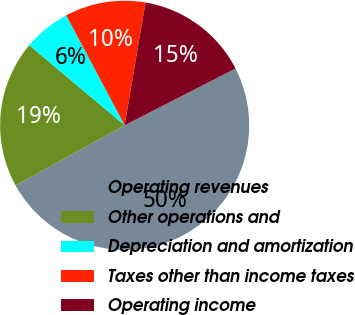Convert chart to OTSL. <chart><loc_0><loc_0><loc_500><loc_500><pie_chart><fcel>Operating revenues<fcel>Other operations and<fcel>Depreciation and amortization<fcel>Taxes other than income taxes<fcel>Operating income<nl><fcel>49.51%<fcel>19.13%<fcel>6.11%<fcel>10.45%<fcel>14.79%<nl></chart> 